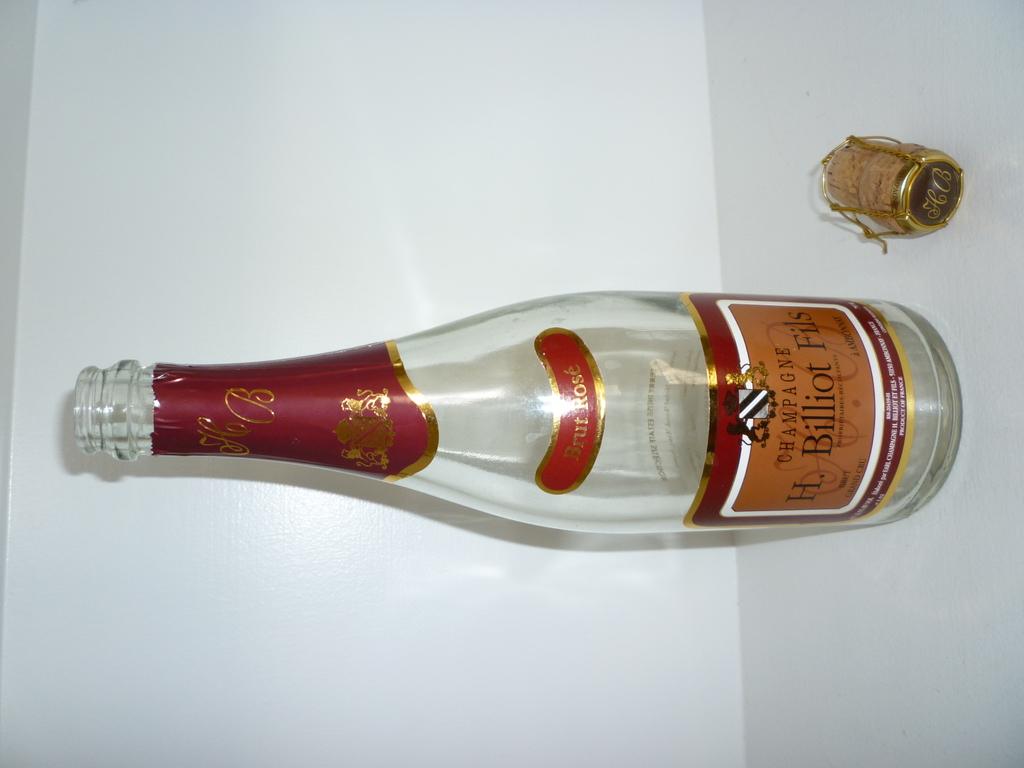Where was it made?
Your answer should be very brief. France. 